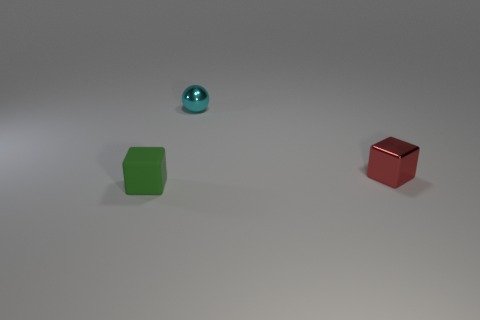There is a red metal object that is the same shape as the tiny matte object; what is its size?
Make the answer very short. Small. What is the size of the object that is both in front of the metallic sphere and behind the tiny green block?
Ensure brevity in your answer.  Small. Do the matte thing and the small object that is right of the cyan object have the same color?
Keep it short and to the point. No. What number of yellow objects are either tiny shiny balls or small rubber things?
Offer a very short reply. 0. There is a cyan thing; what shape is it?
Make the answer very short. Sphere. How many other things are there of the same shape as the small red object?
Give a very brief answer. 1. There is a small cube that is behind the small green rubber cube; what is its color?
Make the answer very short. Red. Does the sphere have the same material as the red thing?
Ensure brevity in your answer.  Yes. How many objects are either cyan metallic cubes or green matte blocks that are to the left of the tiny cyan metal sphere?
Provide a short and direct response. 1. The small object on the right side of the small sphere has what shape?
Provide a short and direct response. Cube. 